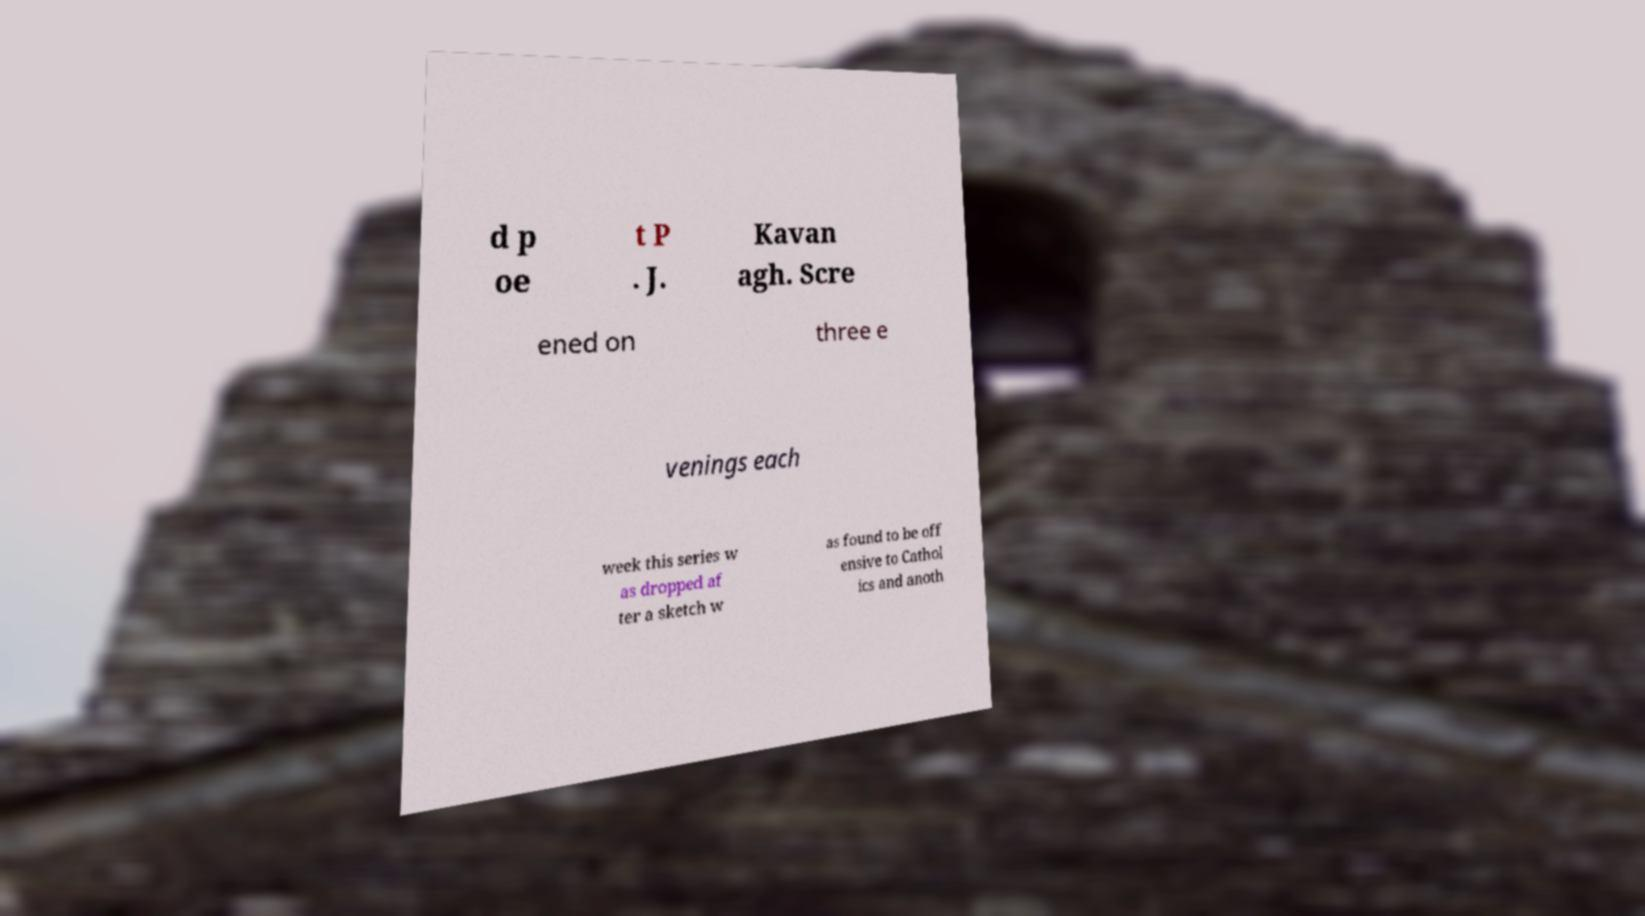Please identify and transcribe the text found in this image. d p oe t P . J. Kavan agh. Scre ened on three e venings each week this series w as dropped af ter a sketch w as found to be off ensive to Cathol ics and anoth 